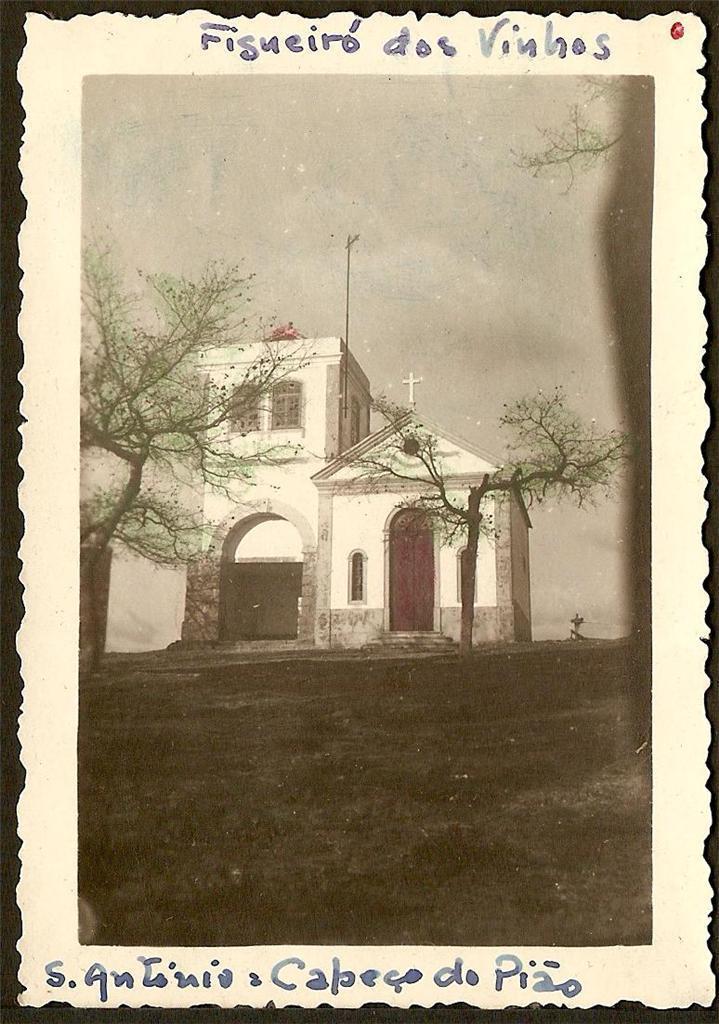How would you summarize this image in a sentence or two? In this image I can see the photo. In the photo I can see the trees and the house with windows. In the background I can see the sky. 